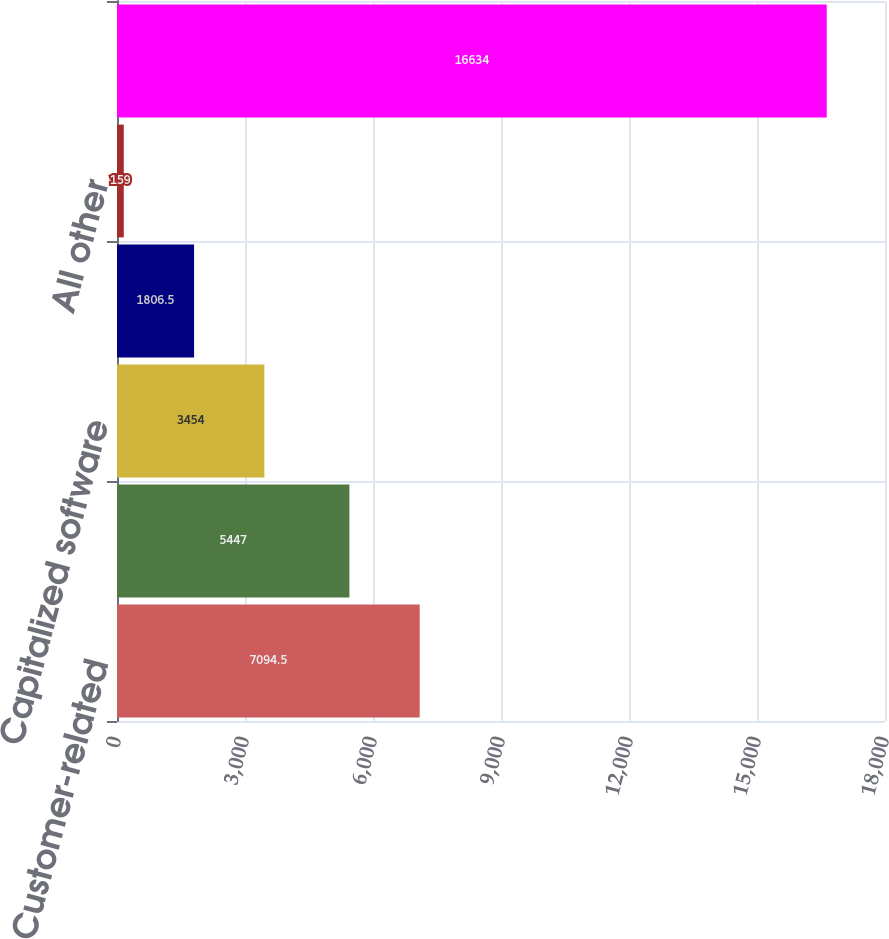<chart> <loc_0><loc_0><loc_500><loc_500><bar_chart><fcel>Customer-related<fcel>Patents and technology<fcel>Capitalized software<fcel>Trademarks<fcel>All other<fcel>Total<nl><fcel>7094.5<fcel>5447<fcel>3454<fcel>1806.5<fcel>159<fcel>16634<nl></chart> 